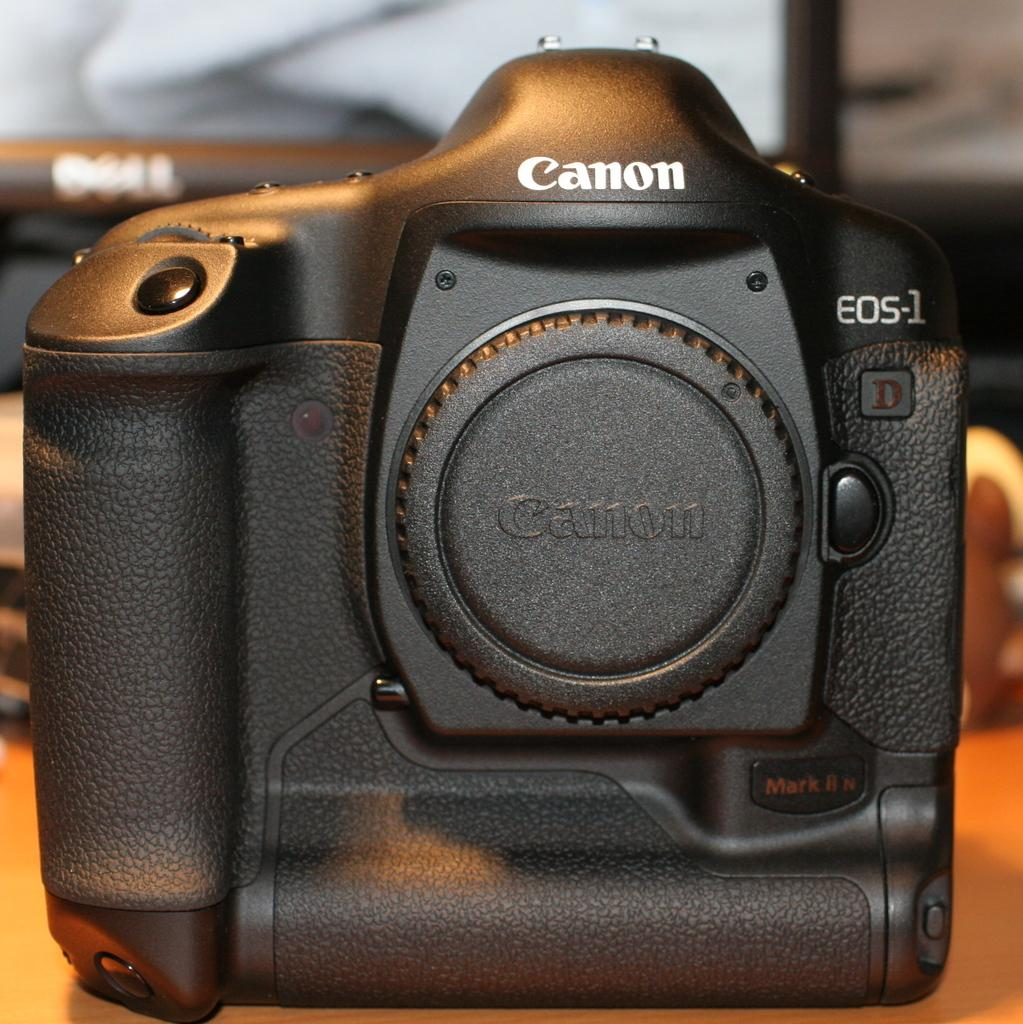What type of camera is in the image? There is a canon camera in the image. Where is the camera located? The camera is on a table. What color is the camera? The camera is black in color. What else can be seen in the image besides the camera? There is a desktop visible in the image. What type of trade is being conducted in the image? There is no indication of any trade being conducted in the image; it primarily features a canon camera on a table. What is the zephyr's role in the image? There is no zephyr present in the image. 